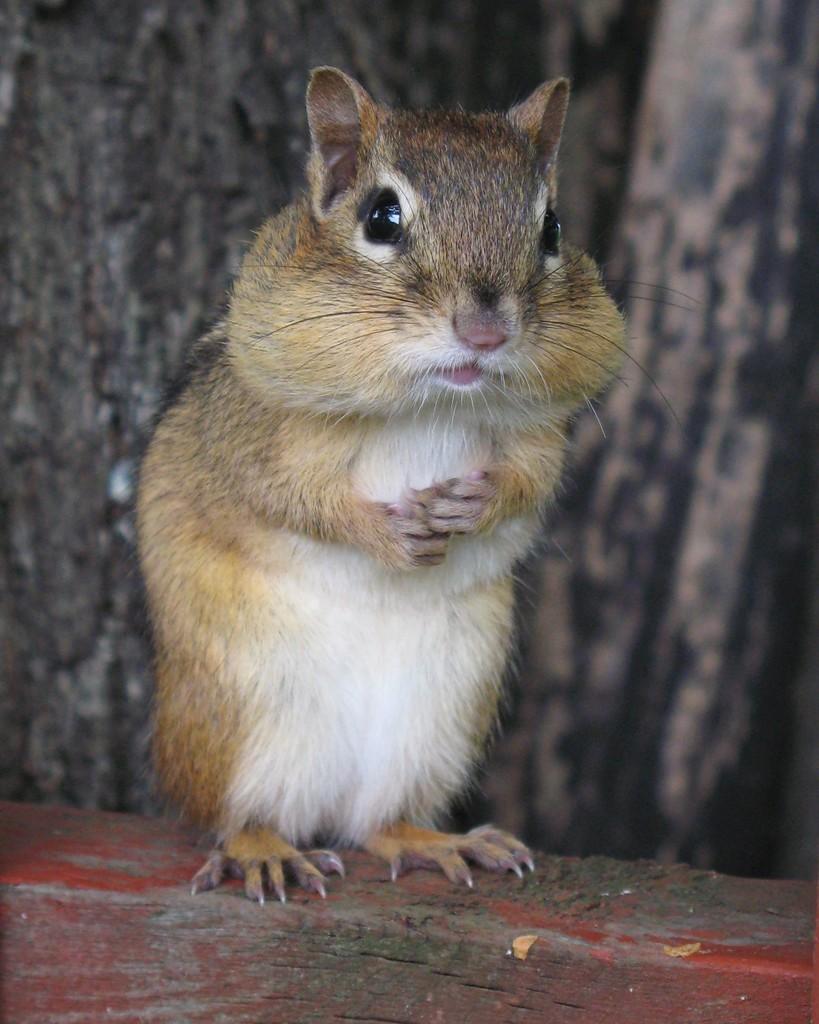In one or two sentences, can you explain what this image depicts? In the image there is a squirrel standing on the wooden log. Behind the squirrel there is a blur background. 